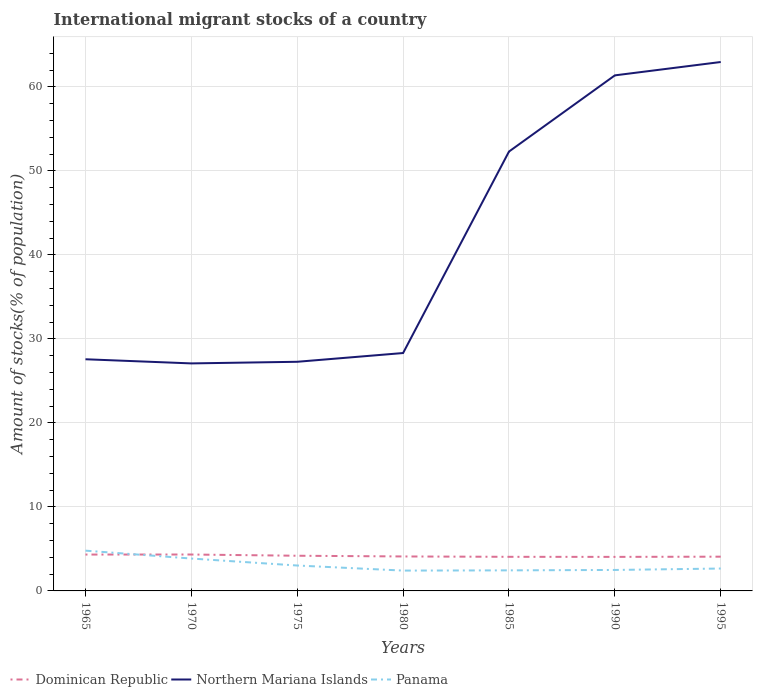How many different coloured lines are there?
Make the answer very short. 3. Across all years, what is the maximum amount of stocks in in Dominican Republic?
Your answer should be compact. 4.05. In which year was the amount of stocks in in Dominican Republic maximum?
Make the answer very short. 1990. What is the total amount of stocks in in Northern Mariana Islands in the graph?
Keep it short and to the point. -34.1. What is the difference between the highest and the second highest amount of stocks in in Northern Mariana Islands?
Your answer should be very brief. 35.88. How many years are there in the graph?
Your answer should be compact. 7. Are the values on the major ticks of Y-axis written in scientific E-notation?
Your answer should be compact. No. Where does the legend appear in the graph?
Your answer should be compact. Bottom left. How many legend labels are there?
Offer a very short reply. 3. How are the legend labels stacked?
Offer a very short reply. Horizontal. What is the title of the graph?
Ensure brevity in your answer.  International migrant stocks of a country. Does "East Asia (developing only)" appear as one of the legend labels in the graph?
Make the answer very short. No. What is the label or title of the X-axis?
Offer a terse response. Years. What is the label or title of the Y-axis?
Keep it short and to the point. Amount of stocks(% of population). What is the Amount of stocks(% of population) of Dominican Republic in 1965?
Ensure brevity in your answer.  4.33. What is the Amount of stocks(% of population) of Northern Mariana Islands in 1965?
Give a very brief answer. 27.58. What is the Amount of stocks(% of population) in Panama in 1965?
Offer a very short reply. 4.79. What is the Amount of stocks(% of population) in Dominican Republic in 1970?
Keep it short and to the point. 4.33. What is the Amount of stocks(% of population) of Northern Mariana Islands in 1970?
Make the answer very short. 27.08. What is the Amount of stocks(% of population) in Panama in 1970?
Your response must be concise. 3.85. What is the Amount of stocks(% of population) of Dominican Republic in 1975?
Keep it short and to the point. 4.19. What is the Amount of stocks(% of population) in Northern Mariana Islands in 1975?
Your response must be concise. 27.28. What is the Amount of stocks(% of population) of Panama in 1975?
Your answer should be compact. 3.02. What is the Amount of stocks(% of population) of Dominican Republic in 1980?
Keep it short and to the point. 4.1. What is the Amount of stocks(% of population) in Northern Mariana Islands in 1980?
Your response must be concise. 28.32. What is the Amount of stocks(% of population) of Panama in 1980?
Your response must be concise. 2.42. What is the Amount of stocks(% of population) in Dominican Republic in 1985?
Keep it short and to the point. 4.06. What is the Amount of stocks(% of population) in Northern Mariana Islands in 1985?
Give a very brief answer. 52.31. What is the Amount of stocks(% of population) in Panama in 1985?
Your answer should be very brief. 2.45. What is the Amount of stocks(% of population) of Dominican Republic in 1990?
Offer a very short reply. 4.05. What is the Amount of stocks(% of population) in Northern Mariana Islands in 1990?
Make the answer very short. 61.38. What is the Amount of stocks(% of population) of Panama in 1990?
Provide a succinct answer. 2.5. What is the Amount of stocks(% of population) of Dominican Republic in 1995?
Your response must be concise. 4.08. What is the Amount of stocks(% of population) of Northern Mariana Islands in 1995?
Make the answer very short. 62.97. What is the Amount of stocks(% of population) in Panama in 1995?
Your answer should be very brief. 2.67. Across all years, what is the maximum Amount of stocks(% of population) of Dominican Republic?
Offer a very short reply. 4.33. Across all years, what is the maximum Amount of stocks(% of population) in Northern Mariana Islands?
Give a very brief answer. 62.97. Across all years, what is the maximum Amount of stocks(% of population) of Panama?
Offer a terse response. 4.79. Across all years, what is the minimum Amount of stocks(% of population) in Dominican Republic?
Offer a terse response. 4.05. Across all years, what is the minimum Amount of stocks(% of population) of Northern Mariana Islands?
Give a very brief answer. 27.08. Across all years, what is the minimum Amount of stocks(% of population) of Panama?
Keep it short and to the point. 2.42. What is the total Amount of stocks(% of population) in Dominican Republic in the graph?
Ensure brevity in your answer.  29.15. What is the total Amount of stocks(% of population) of Northern Mariana Islands in the graph?
Keep it short and to the point. 286.91. What is the total Amount of stocks(% of population) in Panama in the graph?
Your answer should be very brief. 21.7. What is the difference between the Amount of stocks(% of population) of Dominican Republic in 1965 and that in 1970?
Your response must be concise. -0. What is the difference between the Amount of stocks(% of population) in Northern Mariana Islands in 1965 and that in 1970?
Your response must be concise. 0.49. What is the difference between the Amount of stocks(% of population) of Panama in 1965 and that in 1970?
Your response must be concise. 0.94. What is the difference between the Amount of stocks(% of population) in Dominican Republic in 1965 and that in 1975?
Provide a short and direct response. 0.14. What is the difference between the Amount of stocks(% of population) of Northern Mariana Islands in 1965 and that in 1975?
Give a very brief answer. 0.3. What is the difference between the Amount of stocks(% of population) of Panama in 1965 and that in 1975?
Your response must be concise. 1.77. What is the difference between the Amount of stocks(% of population) in Dominican Republic in 1965 and that in 1980?
Ensure brevity in your answer.  0.23. What is the difference between the Amount of stocks(% of population) in Northern Mariana Islands in 1965 and that in 1980?
Ensure brevity in your answer.  -0.74. What is the difference between the Amount of stocks(% of population) of Panama in 1965 and that in 1980?
Your response must be concise. 2.37. What is the difference between the Amount of stocks(% of population) in Dominican Republic in 1965 and that in 1985?
Keep it short and to the point. 0.27. What is the difference between the Amount of stocks(% of population) in Northern Mariana Islands in 1965 and that in 1985?
Give a very brief answer. -24.73. What is the difference between the Amount of stocks(% of population) in Panama in 1965 and that in 1985?
Ensure brevity in your answer.  2.35. What is the difference between the Amount of stocks(% of population) in Dominican Republic in 1965 and that in 1990?
Keep it short and to the point. 0.28. What is the difference between the Amount of stocks(% of population) in Northern Mariana Islands in 1965 and that in 1990?
Offer a terse response. -33.8. What is the difference between the Amount of stocks(% of population) in Panama in 1965 and that in 1990?
Offer a very short reply. 2.3. What is the difference between the Amount of stocks(% of population) of Dominican Republic in 1965 and that in 1995?
Ensure brevity in your answer.  0.25. What is the difference between the Amount of stocks(% of population) of Northern Mariana Islands in 1965 and that in 1995?
Offer a very short reply. -35.39. What is the difference between the Amount of stocks(% of population) of Panama in 1965 and that in 1995?
Give a very brief answer. 2.13. What is the difference between the Amount of stocks(% of population) in Dominican Republic in 1970 and that in 1975?
Offer a terse response. 0.15. What is the difference between the Amount of stocks(% of population) of Northern Mariana Islands in 1970 and that in 1975?
Ensure brevity in your answer.  -0.19. What is the difference between the Amount of stocks(% of population) in Panama in 1970 and that in 1975?
Your answer should be very brief. 0.83. What is the difference between the Amount of stocks(% of population) in Dominican Republic in 1970 and that in 1980?
Ensure brevity in your answer.  0.23. What is the difference between the Amount of stocks(% of population) of Northern Mariana Islands in 1970 and that in 1980?
Provide a short and direct response. -1.24. What is the difference between the Amount of stocks(% of population) in Panama in 1970 and that in 1980?
Provide a short and direct response. 1.43. What is the difference between the Amount of stocks(% of population) in Dominican Republic in 1970 and that in 1985?
Your answer should be very brief. 0.27. What is the difference between the Amount of stocks(% of population) of Northern Mariana Islands in 1970 and that in 1985?
Provide a succinct answer. -25.22. What is the difference between the Amount of stocks(% of population) in Panama in 1970 and that in 1985?
Offer a terse response. 1.41. What is the difference between the Amount of stocks(% of population) of Dominican Republic in 1970 and that in 1990?
Your answer should be very brief. 0.28. What is the difference between the Amount of stocks(% of population) in Northern Mariana Islands in 1970 and that in 1990?
Make the answer very short. -34.29. What is the difference between the Amount of stocks(% of population) in Panama in 1970 and that in 1990?
Your response must be concise. 1.36. What is the difference between the Amount of stocks(% of population) of Dominican Republic in 1970 and that in 1995?
Ensure brevity in your answer.  0.26. What is the difference between the Amount of stocks(% of population) of Northern Mariana Islands in 1970 and that in 1995?
Your answer should be very brief. -35.88. What is the difference between the Amount of stocks(% of population) in Panama in 1970 and that in 1995?
Provide a short and direct response. 1.19. What is the difference between the Amount of stocks(% of population) of Dominican Republic in 1975 and that in 1980?
Give a very brief answer. 0.08. What is the difference between the Amount of stocks(% of population) in Northern Mariana Islands in 1975 and that in 1980?
Keep it short and to the point. -1.04. What is the difference between the Amount of stocks(% of population) of Panama in 1975 and that in 1980?
Offer a very short reply. 0.6. What is the difference between the Amount of stocks(% of population) of Dominican Republic in 1975 and that in 1985?
Your answer should be very brief. 0.13. What is the difference between the Amount of stocks(% of population) in Northern Mariana Islands in 1975 and that in 1985?
Your answer should be compact. -25.03. What is the difference between the Amount of stocks(% of population) of Panama in 1975 and that in 1985?
Your answer should be compact. 0.58. What is the difference between the Amount of stocks(% of population) in Dominican Republic in 1975 and that in 1990?
Keep it short and to the point. 0.14. What is the difference between the Amount of stocks(% of population) of Northern Mariana Islands in 1975 and that in 1990?
Your response must be concise. -34.1. What is the difference between the Amount of stocks(% of population) of Panama in 1975 and that in 1990?
Offer a very short reply. 0.53. What is the difference between the Amount of stocks(% of population) of Dominican Republic in 1975 and that in 1995?
Your answer should be very brief. 0.11. What is the difference between the Amount of stocks(% of population) of Northern Mariana Islands in 1975 and that in 1995?
Your answer should be very brief. -35.69. What is the difference between the Amount of stocks(% of population) of Panama in 1975 and that in 1995?
Your answer should be compact. 0.36. What is the difference between the Amount of stocks(% of population) of Dominican Republic in 1980 and that in 1985?
Your response must be concise. 0.04. What is the difference between the Amount of stocks(% of population) in Northern Mariana Islands in 1980 and that in 1985?
Provide a succinct answer. -23.99. What is the difference between the Amount of stocks(% of population) of Panama in 1980 and that in 1985?
Your response must be concise. -0.03. What is the difference between the Amount of stocks(% of population) in Dominican Republic in 1980 and that in 1990?
Give a very brief answer. 0.05. What is the difference between the Amount of stocks(% of population) in Northern Mariana Islands in 1980 and that in 1990?
Your answer should be compact. -33.06. What is the difference between the Amount of stocks(% of population) in Panama in 1980 and that in 1990?
Offer a very short reply. -0.08. What is the difference between the Amount of stocks(% of population) of Dominican Republic in 1980 and that in 1995?
Your answer should be very brief. 0.03. What is the difference between the Amount of stocks(% of population) of Northern Mariana Islands in 1980 and that in 1995?
Your response must be concise. -34.65. What is the difference between the Amount of stocks(% of population) of Panama in 1980 and that in 1995?
Provide a short and direct response. -0.25. What is the difference between the Amount of stocks(% of population) of Dominican Republic in 1985 and that in 1990?
Your answer should be compact. 0.01. What is the difference between the Amount of stocks(% of population) of Northern Mariana Islands in 1985 and that in 1990?
Ensure brevity in your answer.  -9.07. What is the difference between the Amount of stocks(% of population) in Panama in 1985 and that in 1990?
Offer a very short reply. -0.05. What is the difference between the Amount of stocks(% of population) in Dominican Republic in 1985 and that in 1995?
Make the answer very short. -0.02. What is the difference between the Amount of stocks(% of population) of Northern Mariana Islands in 1985 and that in 1995?
Ensure brevity in your answer.  -10.66. What is the difference between the Amount of stocks(% of population) in Panama in 1985 and that in 1995?
Provide a succinct answer. -0.22. What is the difference between the Amount of stocks(% of population) of Dominican Republic in 1990 and that in 1995?
Ensure brevity in your answer.  -0.02. What is the difference between the Amount of stocks(% of population) in Northern Mariana Islands in 1990 and that in 1995?
Provide a succinct answer. -1.59. What is the difference between the Amount of stocks(% of population) in Panama in 1990 and that in 1995?
Offer a very short reply. -0.17. What is the difference between the Amount of stocks(% of population) of Dominican Republic in 1965 and the Amount of stocks(% of population) of Northern Mariana Islands in 1970?
Give a very brief answer. -22.75. What is the difference between the Amount of stocks(% of population) of Dominican Republic in 1965 and the Amount of stocks(% of population) of Panama in 1970?
Offer a terse response. 0.48. What is the difference between the Amount of stocks(% of population) of Northern Mariana Islands in 1965 and the Amount of stocks(% of population) of Panama in 1970?
Your response must be concise. 23.72. What is the difference between the Amount of stocks(% of population) in Dominican Republic in 1965 and the Amount of stocks(% of population) in Northern Mariana Islands in 1975?
Give a very brief answer. -22.95. What is the difference between the Amount of stocks(% of population) of Dominican Republic in 1965 and the Amount of stocks(% of population) of Panama in 1975?
Keep it short and to the point. 1.31. What is the difference between the Amount of stocks(% of population) in Northern Mariana Islands in 1965 and the Amount of stocks(% of population) in Panama in 1975?
Make the answer very short. 24.55. What is the difference between the Amount of stocks(% of population) in Dominican Republic in 1965 and the Amount of stocks(% of population) in Northern Mariana Islands in 1980?
Your response must be concise. -23.99. What is the difference between the Amount of stocks(% of population) in Dominican Republic in 1965 and the Amount of stocks(% of population) in Panama in 1980?
Offer a terse response. 1.91. What is the difference between the Amount of stocks(% of population) in Northern Mariana Islands in 1965 and the Amount of stocks(% of population) in Panama in 1980?
Your answer should be very brief. 25.16. What is the difference between the Amount of stocks(% of population) in Dominican Republic in 1965 and the Amount of stocks(% of population) in Northern Mariana Islands in 1985?
Your answer should be very brief. -47.97. What is the difference between the Amount of stocks(% of population) in Dominican Republic in 1965 and the Amount of stocks(% of population) in Panama in 1985?
Make the answer very short. 1.88. What is the difference between the Amount of stocks(% of population) of Northern Mariana Islands in 1965 and the Amount of stocks(% of population) of Panama in 1985?
Make the answer very short. 25.13. What is the difference between the Amount of stocks(% of population) in Dominican Republic in 1965 and the Amount of stocks(% of population) in Northern Mariana Islands in 1990?
Make the answer very short. -57.04. What is the difference between the Amount of stocks(% of population) of Dominican Republic in 1965 and the Amount of stocks(% of population) of Panama in 1990?
Your answer should be compact. 1.83. What is the difference between the Amount of stocks(% of population) of Northern Mariana Islands in 1965 and the Amount of stocks(% of population) of Panama in 1990?
Offer a terse response. 25.08. What is the difference between the Amount of stocks(% of population) of Dominican Republic in 1965 and the Amount of stocks(% of population) of Northern Mariana Islands in 1995?
Your answer should be very brief. -58.64. What is the difference between the Amount of stocks(% of population) of Dominican Republic in 1965 and the Amount of stocks(% of population) of Panama in 1995?
Your response must be concise. 1.66. What is the difference between the Amount of stocks(% of population) in Northern Mariana Islands in 1965 and the Amount of stocks(% of population) in Panama in 1995?
Make the answer very short. 24.91. What is the difference between the Amount of stocks(% of population) of Dominican Republic in 1970 and the Amount of stocks(% of population) of Northern Mariana Islands in 1975?
Provide a succinct answer. -22.94. What is the difference between the Amount of stocks(% of population) in Dominican Republic in 1970 and the Amount of stocks(% of population) in Panama in 1975?
Offer a very short reply. 1.31. What is the difference between the Amount of stocks(% of population) in Northern Mariana Islands in 1970 and the Amount of stocks(% of population) in Panama in 1975?
Your response must be concise. 24.06. What is the difference between the Amount of stocks(% of population) of Dominican Republic in 1970 and the Amount of stocks(% of population) of Northern Mariana Islands in 1980?
Give a very brief answer. -23.99. What is the difference between the Amount of stocks(% of population) of Dominican Republic in 1970 and the Amount of stocks(% of population) of Panama in 1980?
Your answer should be very brief. 1.91. What is the difference between the Amount of stocks(% of population) in Northern Mariana Islands in 1970 and the Amount of stocks(% of population) in Panama in 1980?
Provide a short and direct response. 24.66. What is the difference between the Amount of stocks(% of population) of Dominican Republic in 1970 and the Amount of stocks(% of population) of Northern Mariana Islands in 1985?
Offer a very short reply. -47.97. What is the difference between the Amount of stocks(% of population) in Dominican Republic in 1970 and the Amount of stocks(% of population) in Panama in 1985?
Give a very brief answer. 1.89. What is the difference between the Amount of stocks(% of population) of Northern Mariana Islands in 1970 and the Amount of stocks(% of population) of Panama in 1985?
Make the answer very short. 24.64. What is the difference between the Amount of stocks(% of population) in Dominican Republic in 1970 and the Amount of stocks(% of population) in Northern Mariana Islands in 1990?
Your answer should be compact. -57.04. What is the difference between the Amount of stocks(% of population) in Dominican Republic in 1970 and the Amount of stocks(% of population) in Panama in 1990?
Your answer should be compact. 1.84. What is the difference between the Amount of stocks(% of population) of Northern Mariana Islands in 1970 and the Amount of stocks(% of population) of Panama in 1990?
Provide a short and direct response. 24.59. What is the difference between the Amount of stocks(% of population) of Dominican Republic in 1970 and the Amount of stocks(% of population) of Northern Mariana Islands in 1995?
Provide a short and direct response. -58.63. What is the difference between the Amount of stocks(% of population) in Dominican Republic in 1970 and the Amount of stocks(% of population) in Panama in 1995?
Your answer should be very brief. 1.67. What is the difference between the Amount of stocks(% of population) in Northern Mariana Islands in 1970 and the Amount of stocks(% of population) in Panama in 1995?
Offer a very short reply. 24.42. What is the difference between the Amount of stocks(% of population) in Dominican Republic in 1975 and the Amount of stocks(% of population) in Northern Mariana Islands in 1980?
Keep it short and to the point. -24.13. What is the difference between the Amount of stocks(% of population) of Dominican Republic in 1975 and the Amount of stocks(% of population) of Panama in 1980?
Your answer should be compact. 1.77. What is the difference between the Amount of stocks(% of population) of Northern Mariana Islands in 1975 and the Amount of stocks(% of population) of Panama in 1980?
Your response must be concise. 24.86. What is the difference between the Amount of stocks(% of population) of Dominican Republic in 1975 and the Amount of stocks(% of population) of Northern Mariana Islands in 1985?
Provide a short and direct response. -48.12. What is the difference between the Amount of stocks(% of population) of Dominican Republic in 1975 and the Amount of stocks(% of population) of Panama in 1985?
Provide a short and direct response. 1.74. What is the difference between the Amount of stocks(% of population) of Northern Mariana Islands in 1975 and the Amount of stocks(% of population) of Panama in 1985?
Ensure brevity in your answer.  24.83. What is the difference between the Amount of stocks(% of population) of Dominican Republic in 1975 and the Amount of stocks(% of population) of Northern Mariana Islands in 1990?
Your response must be concise. -57.19. What is the difference between the Amount of stocks(% of population) in Dominican Republic in 1975 and the Amount of stocks(% of population) in Panama in 1990?
Your response must be concise. 1.69. What is the difference between the Amount of stocks(% of population) in Northern Mariana Islands in 1975 and the Amount of stocks(% of population) in Panama in 1990?
Offer a terse response. 24.78. What is the difference between the Amount of stocks(% of population) in Dominican Republic in 1975 and the Amount of stocks(% of population) in Northern Mariana Islands in 1995?
Give a very brief answer. -58.78. What is the difference between the Amount of stocks(% of population) in Dominican Republic in 1975 and the Amount of stocks(% of population) in Panama in 1995?
Give a very brief answer. 1.52. What is the difference between the Amount of stocks(% of population) of Northern Mariana Islands in 1975 and the Amount of stocks(% of population) of Panama in 1995?
Ensure brevity in your answer.  24.61. What is the difference between the Amount of stocks(% of population) of Dominican Republic in 1980 and the Amount of stocks(% of population) of Northern Mariana Islands in 1985?
Keep it short and to the point. -48.2. What is the difference between the Amount of stocks(% of population) in Dominican Republic in 1980 and the Amount of stocks(% of population) in Panama in 1985?
Make the answer very short. 1.66. What is the difference between the Amount of stocks(% of population) in Northern Mariana Islands in 1980 and the Amount of stocks(% of population) in Panama in 1985?
Provide a short and direct response. 25.87. What is the difference between the Amount of stocks(% of population) in Dominican Republic in 1980 and the Amount of stocks(% of population) in Northern Mariana Islands in 1990?
Offer a very short reply. -57.27. What is the difference between the Amount of stocks(% of population) in Dominican Republic in 1980 and the Amount of stocks(% of population) in Panama in 1990?
Provide a short and direct response. 1.61. What is the difference between the Amount of stocks(% of population) in Northern Mariana Islands in 1980 and the Amount of stocks(% of population) in Panama in 1990?
Provide a short and direct response. 25.82. What is the difference between the Amount of stocks(% of population) of Dominican Republic in 1980 and the Amount of stocks(% of population) of Northern Mariana Islands in 1995?
Provide a succinct answer. -58.86. What is the difference between the Amount of stocks(% of population) of Dominican Republic in 1980 and the Amount of stocks(% of population) of Panama in 1995?
Offer a very short reply. 1.44. What is the difference between the Amount of stocks(% of population) in Northern Mariana Islands in 1980 and the Amount of stocks(% of population) in Panama in 1995?
Provide a short and direct response. 25.65. What is the difference between the Amount of stocks(% of population) in Dominican Republic in 1985 and the Amount of stocks(% of population) in Northern Mariana Islands in 1990?
Keep it short and to the point. -57.32. What is the difference between the Amount of stocks(% of population) in Dominican Republic in 1985 and the Amount of stocks(% of population) in Panama in 1990?
Your answer should be compact. 1.56. What is the difference between the Amount of stocks(% of population) of Northern Mariana Islands in 1985 and the Amount of stocks(% of population) of Panama in 1990?
Your answer should be compact. 49.81. What is the difference between the Amount of stocks(% of population) of Dominican Republic in 1985 and the Amount of stocks(% of population) of Northern Mariana Islands in 1995?
Your answer should be compact. -58.91. What is the difference between the Amount of stocks(% of population) of Dominican Republic in 1985 and the Amount of stocks(% of population) of Panama in 1995?
Ensure brevity in your answer.  1.39. What is the difference between the Amount of stocks(% of population) of Northern Mariana Islands in 1985 and the Amount of stocks(% of population) of Panama in 1995?
Your answer should be compact. 49.64. What is the difference between the Amount of stocks(% of population) in Dominican Republic in 1990 and the Amount of stocks(% of population) in Northern Mariana Islands in 1995?
Offer a terse response. -58.91. What is the difference between the Amount of stocks(% of population) of Dominican Republic in 1990 and the Amount of stocks(% of population) of Panama in 1995?
Provide a short and direct response. 1.39. What is the difference between the Amount of stocks(% of population) of Northern Mariana Islands in 1990 and the Amount of stocks(% of population) of Panama in 1995?
Offer a terse response. 58.71. What is the average Amount of stocks(% of population) in Dominican Republic per year?
Your answer should be very brief. 4.16. What is the average Amount of stocks(% of population) in Northern Mariana Islands per year?
Provide a succinct answer. 40.99. What is the average Amount of stocks(% of population) in Panama per year?
Your response must be concise. 3.1. In the year 1965, what is the difference between the Amount of stocks(% of population) of Dominican Republic and Amount of stocks(% of population) of Northern Mariana Islands?
Provide a short and direct response. -23.25. In the year 1965, what is the difference between the Amount of stocks(% of population) in Dominican Republic and Amount of stocks(% of population) in Panama?
Your response must be concise. -0.46. In the year 1965, what is the difference between the Amount of stocks(% of population) in Northern Mariana Islands and Amount of stocks(% of population) in Panama?
Your answer should be very brief. 22.78. In the year 1970, what is the difference between the Amount of stocks(% of population) of Dominican Republic and Amount of stocks(% of population) of Northern Mariana Islands?
Your answer should be compact. -22.75. In the year 1970, what is the difference between the Amount of stocks(% of population) in Dominican Republic and Amount of stocks(% of population) in Panama?
Offer a terse response. 0.48. In the year 1970, what is the difference between the Amount of stocks(% of population) of Northern Mariana Islands and Amount of stocks(% of population) of Panama?
Your answer should be compact. 23.23. In the year 1975, what is the difference between the Amount of stocks(% of population) in Dominican Republic and Amount of stocks(% of population) in Northern Mariana Islands?
Keep it short and to the point. -23.09. In the year 1975, what is the difference between the Amount of stocks(% of population) in Dominican Republic and Amount of stocks(% of population) in Panama?
Your answer should be very brief. 1.16. In the year 1975, what is the difference between the Amount of stocks(% of population) of Northern Mariana Islands and Amount of stocks(% of population) of Panama?
Your answer should be very brief. 24.25. In the year 1980, what is the difference between the Amount of stocks(% of population) of Dominican Republic and Amount of stocks(% of population) of Northern Mariana Islands?
Ensure brevity in your answer.  -24.22. In the year 1980, what is the difference between the Amount of stocks(% of population) in Dominican Republic and Amount of stocks(% of population) in Panama?
Make the answer very short. 1.68. In the year 1980, what is the difference between the Amount of stocks(% of population) in Northern Mariana Islands and Amount of stocks(% of population) in Panama?
Offer a very short reply. 25.9. In the year 1985, what is the difference between the Amount of stocks(% of population) in Dominican Republic and Amount of stocks(% of population) in Northern Mariana Islands?
Keep it short and to the point. -48.25. In the year 1985, what is the difference between the Amount of stocks(% of population) of Dominican Republic and Amount of stocks(% of population) of Panama?
Provide a short and direct response. 1.61. In the year 1985, what is the difference between the Amount of stocks(% of population) of Northern Mariana Islands and Amount of stocks(% of population) of Panama?
Your response must be concise. 49.86. In the year 1990, what is the difference between the Amount of stocks(% of population) in Dominican Republic and Amount of stocks(% of population) in Northern Mariana Islands?
Your answer should be very brief. -57.32. In the year 1990, what is the difference between the Amount of stocks(% of population) of Dominican Republic and Amount of stocks(% of population) of Panama?
Give a very brief answer. 1.56. In the year 1990, what is the difference between the Amount of stocks(% of population) of Northern Mariana Islands and Amount of stocks(% of population) of Panama?
Make the answer very short. 58.88. In the year 1995, what is the difference between the Amount of stocks(% of population) of Dominican Republic and Amount of stocks(% of population) of Northern Mariana Islands?
Provide a succinct answer. -58.89. In the year 1995, what is the difference between the Amount of stocks(% of population) of Dominican Republic and Amount of stocks(% of population) of Panama?
Make the answer very short. 1.41. In the year 1995, what is the difference between the Amount of stocks(% of population) of Northern Mariana Islands and Amount of stocks(% of population) of Panama?
Your answer should be very brief. 60.3. What is the ratio of the Amount of stocks(% of population) of Northern Mariana Islands in 1965 to that in 1970?
Your response must be concise. 1.02. What is the ratio of the Amount of stocks(% of population) of Panama in 1965 to that in 1970?
Give a very brief answer. 1.24. What is the ratio of the Amount of stocks(% of population) of Dominican Republic in 1965 to that in 1975?
Offer a terse response. 1.03. What is the ratio of the Amount of stocks(% of population) of Northern Mariana Islands in 1965 to that in 1975?
Make the answer very short. 1.01. What is the ratio of the Amount of stocks(% of population) in Panama in 1965 to that in 1975?
Keep it short and to the point. 1.58. What is the ratio of the Amount of stocks(% of population) of Dominican Republic in 1965 to that in 1980?
Offer a very short reply. 1.06. What is the ratio of the Amount of stocks(% of population) of Northern Mariana Islands in 1965 to that in 1980?
Ensure brevity in your answer.  0.97. What is the ratio of the Amount of stocks(% of population) of Panama in 1965 to that in 1980?
Provide a short and direct response. 1.98. What is the ratio of the Amount of stocks(% of population) in Dominican Republic in 1965 to that in 1985?
Offer a terse response. 1.07. What is the ratio of the Amount of stocks(% of population) in Northern Mariana Islands in 1965 to that in 1985?
Your response must be concise. 0.53. What is the ratio of the Amount of stocks(% of population) of Panama in 1965 to that in 1985?
Make the answer very short. 1.96. What is the ratio of the Amount of stocks(% of population) in Dominican Republic in 1965 to that in 1990?
Your answer should be compact. 1.07. What is the ratio of the Amount of stocks(% of population) in Northern Mariana Islands in 1965 to that in 1990?
Give a very brief answer. 0.45. What is the ratio of the Amount of stocks(% of population) of Panama in 1965 to that in 1990?
Your answer should be compact. 1.92. What is the ratio of the Amount of stocks(% of population) in Dominican Republic in 1965 to that in 1995?
Provide a succinct answer. 1.06. What is the ratio of the Amount of stocks(% of population) of Northern Mariana Islands in 1965 to that in 1995?
Give a very brief answer. 0.44. What is the ratio of the Amount of stocks(% of population) in Panama in 1965 to that in 1995?
Keep it short and to the point. 1.8. What is the ratio of the Amount of stocks(% of population) in Dominican Republic in 1970 to that in 1975?
Give a very brief answer. 1.03. What is the ratio of the Amount of stocks(% of population) of Panama in 1970 to that in 1975?
Offer a very short reply. 1.27. What is the ratio of the Amount of stocks(% of population) of Dominican Republic in 1970 to that in 1980?
Your response must be concise. 1.06. What is the ratio of the Amount of stocks(% of population) of Northern Mariana Islands in 1970 to that in 1980?
Offer a terse response. 0.96. What is the ratio of the Amount of stocks(% of population) in Panama in 1970 to that in 1980?
Make the answer very short. 1.59. What is the ratio of the Amount of stocks(% of population) of Dominican Republic in 1970 to that in 1985?
Give a very brief answer. 1.07. What is the ratio of the Amount of stocks(% of population) in Northern Mariana Islands in 1970 to that in 1985?
Keep it short and to the point. 0.52. What is the ratio of the Amount of stocks(% of population) of Panama in 1970 to that in 1985?
Offer a very short reply. 1.57. What is the ratio of the Amount of stocks(% of population) in Dominican Republic in 1970 to that in 1990?
Ensure brevity in your answer.  1.07. What is the ratio of the Amount of stocks(% of population) in Northern Mariana Islands in 1970 to that in 1990?
Ensure brevity in your answer.  0.44. What is the ratio of the Amount of stocks(% of population) in Panama in 1970 to that in 1990?
Offer a very short reply. 1.54. What is the ratio of the Amount of stocks(% of population) in Dominican Republic in 1970 to that in 1995?
Ensure brevity in your answer.  1.06. What is the ratio of the Amount of stocks(% of population) of Northern Mariana Islands in 1970 to that in 1995?
Make the answer very short. 0.43. What is the ratio of the Amount of stocks(% of population) in Panama in 1970 to that in 1995?
Your answer should be very brief. 1.45. What is the ratio of the Amount of stocks(% of population) in Dominican Republic in 1975 to that in 1980?
Offer a terse response. 1.02. What is the ratio of the Amount of stocks(% of population) of Northern Mariana Islands in 1975 to that in 1980?
Your answer should be very brief. 0.96. What is the ratio of the Amount of stocks(% of population) in Panama in 1975 to that in 1980?
Make the answer very short. 1.25. What is the ratio of the Amount of stocks(% of population) of Dominican Republic in 1975 to that in 1985?
Provide a short and direct response. 1.03. What is the ratio of the Amount of stocks(% of population) of Northern Mariana Islands in 1975 to that in 1985?
Give a very brief answer. 0.52. What is the ratio of the Amount of stocks(% of population) in Panama in 1975 to that in 1985?
Provide a succinct answer. 1.24. What is the ratio of the Amount of stocks(% of population) in Dominican Republic in 1975 to that in 1990?
Provide a succinct answer. 1.03. What is the ratio of the Amount of stocks(% of population) in Northern Mariana Islands in 1975 to that in 1990?
Your answer should be compact. 0.44. What is the ratio of the Amount of stocks(% of population) of Panama in 1975 to that in 1990?
Provide a short and direct response. 1.21. What is the ratio of the Amount of stocks(% of population) of Dominican Republic in 1975 to that in 1995?
Offer a terse response. 1.03. What is the ratio of the Amount of stocks(% of population) in Northern Mariana Islands in 1975 to that in 1995?
Keep it short and to the point. 0.43. What is the ratio of the Amount of stocks(% of population) of Panama in 1975 to that in 1995?
Provide a succinct answer. 1.13. What is the ratio of the Amount of stocks(% of population) of Dominican Republic in 1980 to that in 1985?
Your answer should be compact. 1.01. What is the ratio of the Amount of stocks(% of population) in Northern Mariana Islands in 1980 to that in 1985?
Your answer should be compact. 0.54. What is the ratio of the Amount of stocks(% of population) of Panama in 1980 to that in 1985?
Make the answer very short. 0.99. What is the ratio of the Amount of stocks(% of population) of Dominican Republic in 1980 to that in 1990?
Your response must be concise. 1.01. What is the ratio of the Amount of stocks(% of population) in Northern Mariana Islands in 1980 to that in 1990?
Ensure brevity in your answer.  0.46. What is the ratio of the Amount of stocks(% of population) of Panama in 1980 to that in 1990?
Give a very brief answer. 0.97. What is the ratio of the Amount of stocks(% of population) in Northern Mariana Islands in 1980 to that in 1995?
Give a very brief answer. 0.45. What is the ratio of the Amount of stocks(% of population) in Panama in 1980 to that in 1995?
Offer a terse response. 0.91. What is the ratio of the Amount of stocks(% of population) of Dominican Republic in 1985 to that in 1990?
Your answer should be very brief. 1. What is the ratio of the Amount of stocks(% of population) of Northern Mariana Islands in 1985 to that in 1990?
Give a very brief answer. 0.85. What is the ratio of the Amount of stocks(% of population) in Panama in 1985 to that in 1990?
Keep it short and to the point. 0.98. What is the ratio of the Amount of stocks(% of population) in Northern Mariana Islands in 1985 to that in 1995?
Provide a succinct answer. 0.83. What is the ratio of the Amount of stocks(% of population) in Panama in 1985 to that in 1995?
Your answer should be compact. 0.92. What is the ratio of the Amount of stocks(% of population) in Dominican Republic in 1990 to that in 1995?
Give a very brief answer. 0.99. What is the ratio of the Amount of stocks(% of population) in Northern Mariana Islands in 1990 to that in 1995?
Provide a succinct answer. 0.97. What is the ratio of the Amount of stocks(% of population) in Panama in 1990 to that in 1995?
Offer a very short reply. 0.94. What is the difference between the highest and the second highest Amount of stocks(% of population) of Dominican Republic?
Offer a very short reply. 0. What is the difference between the highest and the second highest Amount of stocks(% of population) in Northern Mariana Islands?
Your answer should be very brief. 1.59. What is the difference between the highest and the second highest Amount of stocks(% of population) of Panama?
Keep it short and to the point. 0.94. What is the difference between the highest and the lowest Amount of stocks(% of population) in Dominican Republic?
Offer a very short reply. 0.28. What is the difference between the highest and the lowest Amount of stocks(% of population) of Northern Mariana Islands?
Provide a short and direct response. 35.88. What is the difference between the highest and the lowest Amount of stocks(% of population) in Panama?
Give a very brief answer. 2.37. 